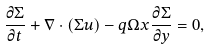Convert formula to latex. <formula><loc_0><loc_0><loc_500><loc_500>\frac { \partial \Sigma } { \partial t } + \nabla \cdot ( \Sigma { u } ) - q \Omega x \frac { \partial \Sigma } { \partial y } = 0 ,</formula> 